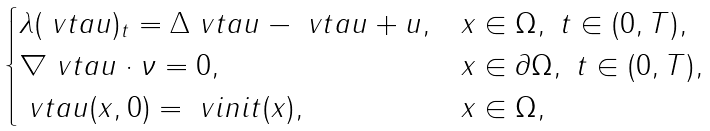Convert formula to latex. <formula><loc_0><loc_0><loc_500><loc_500>\begin{cases} \lambda ( \ v t a u ) _ { t } = \Delta \ v t a u - \ v t a u + u , & x \in \Omega , \ t \in ( 0 , T ) , \\ \nabla \ v t a u \cdot \nu = 0 , & x \in \partial \Omega , \ t \in ( 0 , T ) , \\ \ v t a u ( x , 0 ) = \ v i n i t ( x ) , & x \in \Omega , \end{cases}</formula> 